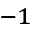<formula> <loc_0><loc_0><loc_500><loc_500>^ { - 1 }</formula> 